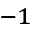<formula> <loc_0><loc_0><loc_500><loc_500>^ { - 1 }</formula> 